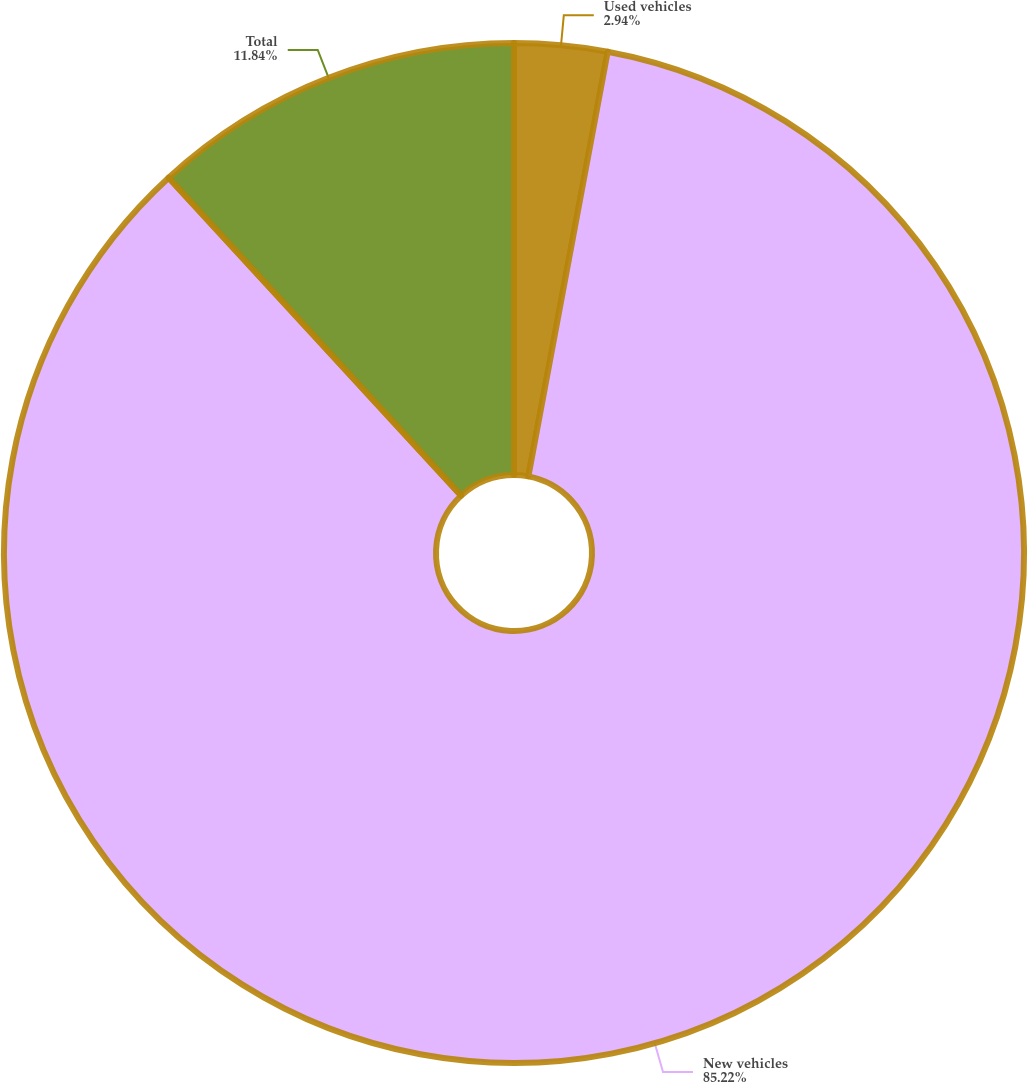<chart> <loc_0><loc_0><loc_500><loc_500><pie_chart><fcel>Used vehicles<fcel>New vehicles<fcel>Total<nl><fcel>2.94%<fcel>85.22%<fcel>11.84%<nl></chart> 